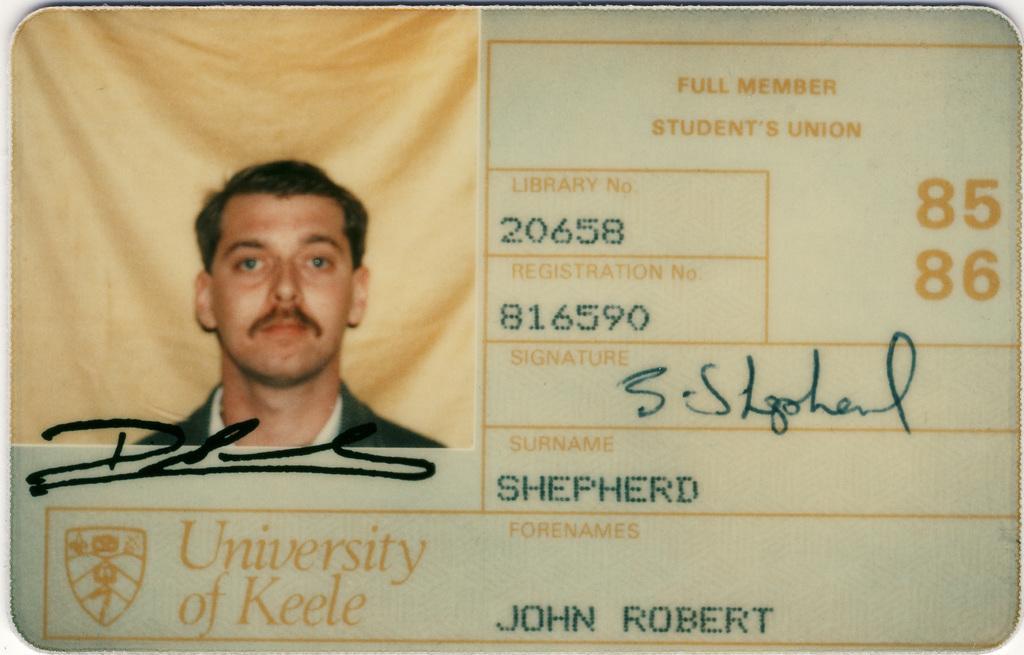In one or two sentences, can you explain what this image depicts? In this image we can see an id card and there is a picture of a man pasted on the id card. There is text. 